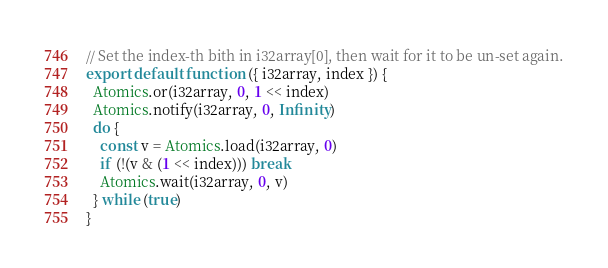Convert code to text. <code><loc_0><loc_0><loc_500><loc_500><_JavaScript_>// Set the index-th bith in i32array[0], then wait for it to be un-set again.
export default function ({ i32array, index }) {
  Atomics.or(i32array, 0, 1 << index)
  Atomics.notify(i32array, 0, Infinity)
  do {
    const v = Atomics.load(i32array, 0)
    if (!(v & (1 << index))) break
    Atomics.wait(i32array, 0, v)
  } while (true)
}
</code> 